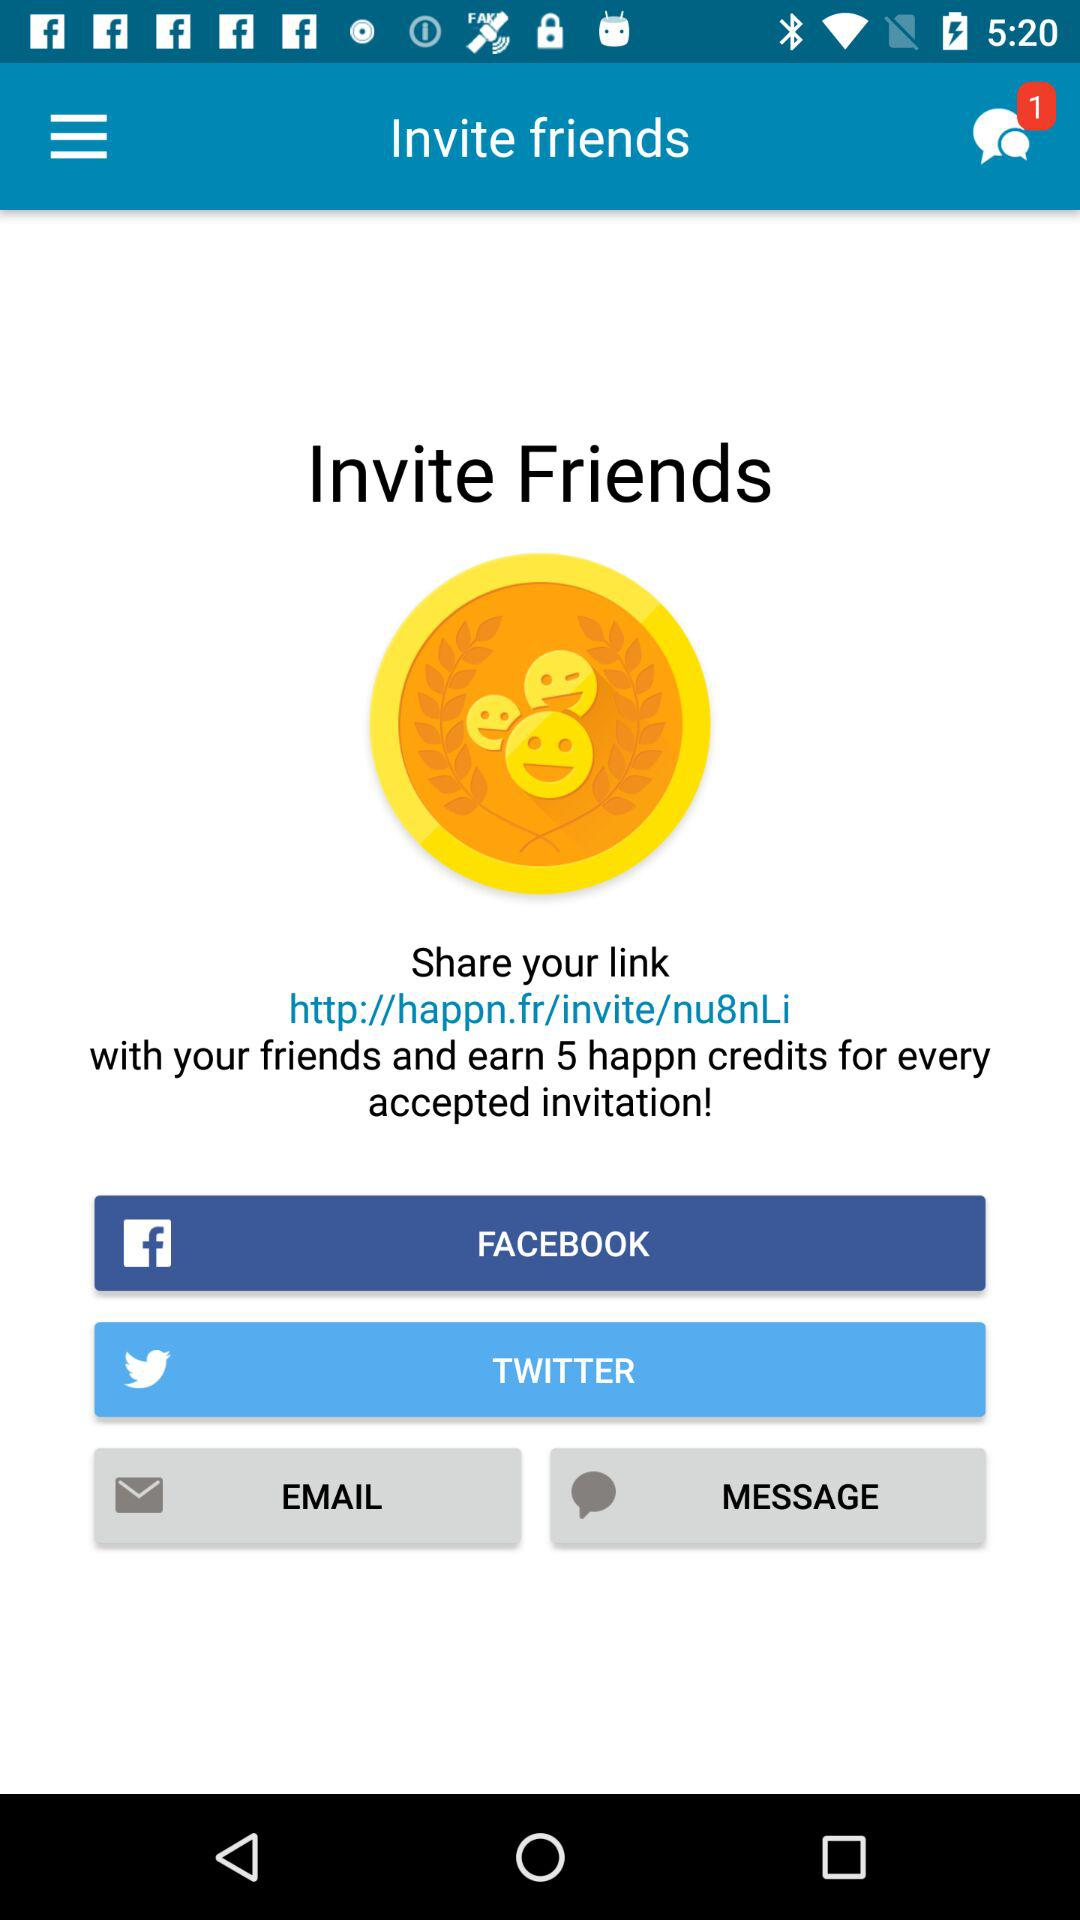How many new chats are available? There is 1 new chat available. 